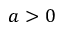<formula> <loc_0><loc_0><loc_500><loc_500>a > 0</formula> 